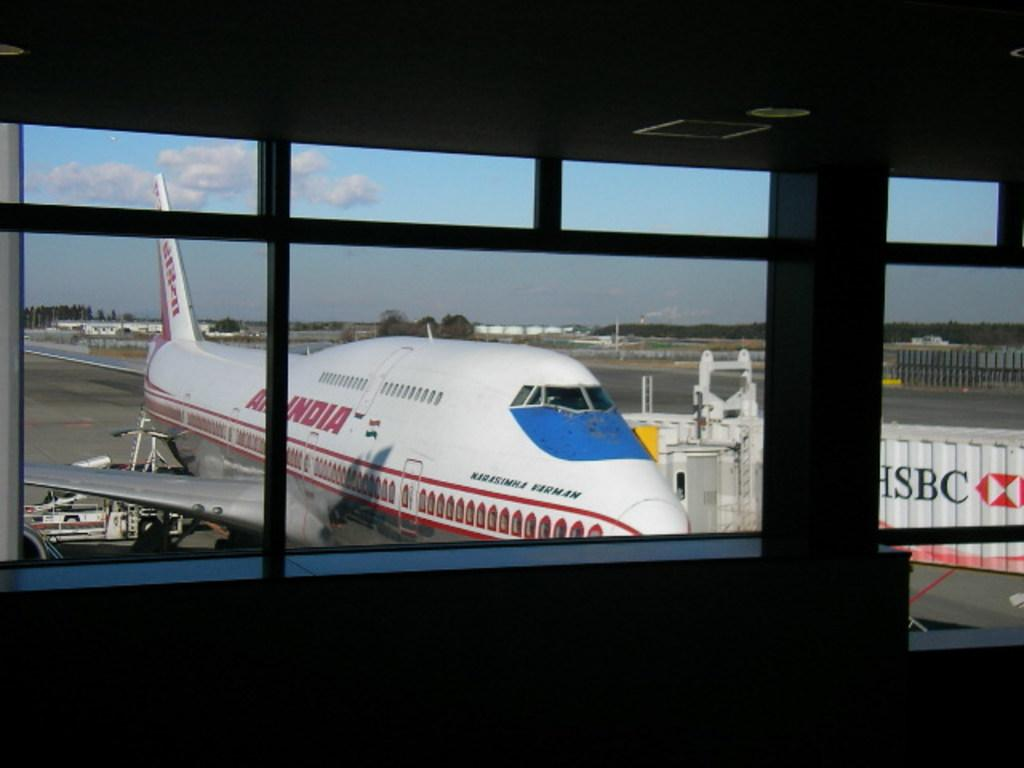<image>
Offer a succinct explanation of the picture presented. outside an airport window is an Air India jet at a gate 